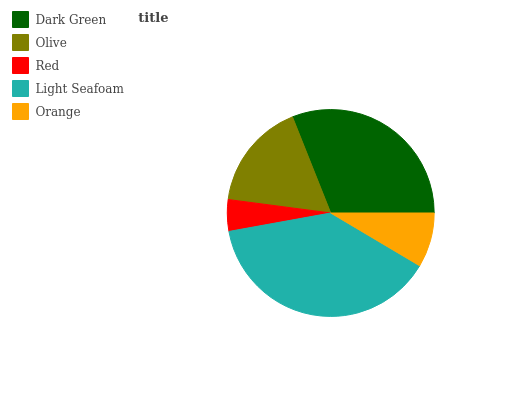Is Red the minimum?
Answer yes or no. Yes. Is Light Seafoam the maximum?
Answer yes or no. Yes. Is Olive the minimum?
Answer yes or no. No. Is Olive the maximum?
Answer yes or no. No. Is Dark Green greater than Olive?
Answer yes or no. Yes. Is Olive less than Dark Green?
Answer yes or no. Yes. Is Olive greater than Dark Green?
Answer yes or no. No. Is Dark Green less than Olive?
Answer yes or no. No. Is Olive the high median?
Answer yes or no. Yes. Is Olive the low median?
Answer yes or no. Yes. Is Red the high median?
Answer yes or no. No. Is Orange the low median?
Answer yes or no. No. 